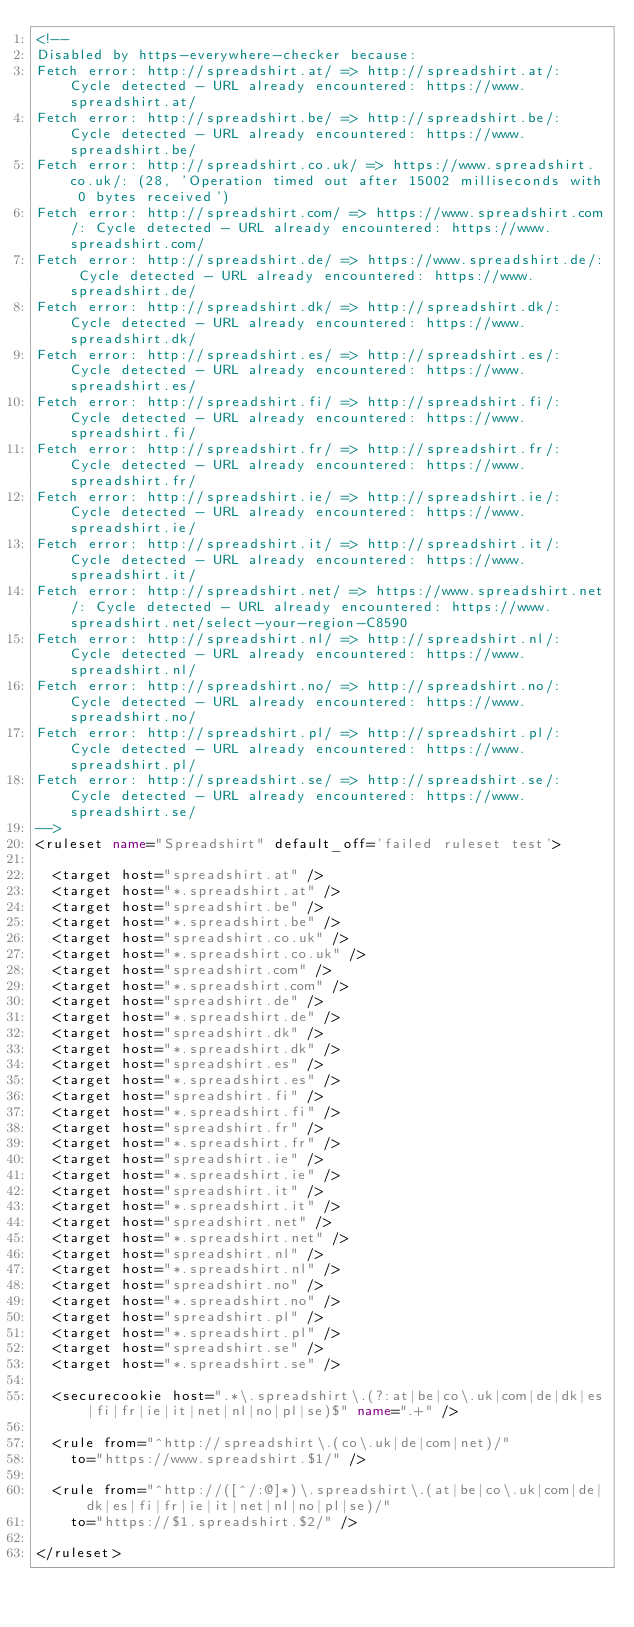<code> <loc_0><loc_0><loc_500><loc_500><_XML_><!--
Disabled by https-everywhere-checker because:
Fetch error: http://spreadshirt.at/ => http://spreadshirt.at/: Cycle detected - URL already encountered: https://www.spreadshirt.at/
Fetch error: http://spreadshirt.be/ => http://spreadshirt.be/: Cycle detected - URL already encountered: https://www.spreadshirt.be/
Fetch error: http://spreadshirt.co.uk/ => https://www.spreadshirt.co.uk/: (28, 'Operation timed out after 15002 milliseconds with 0 bytes received')
Fetch error: http://spreadshirt.com/ => https://www.spreadshirt.com/: Cycle detected - URL already encountered: https://www.spreadshirt.com/
Fetch error: http://spreadshirt.de/ => https://www.spreadshirt.de/: Cycle detected - URL already encountered: https://www.spreadshirt.de/
Fetch error: http://spreadshirt.dk/ => http://spreadshirt.dk/: Cycle detected - URL already encountered: https://www.spreadshirt.dk/
Fetch error: http://spreadshirt.es/ => http://spreadshirt.es/: Cycle detected - URL already encountered: https://www.spreadshirt.es/
Fetch error: http://spreadshirt.fi/ => http://spreadshirt.fi/: Cycle detected - URL already encountered: https://www.spreadshirt.fi/
Fetch error: http://spreadshirt.fr/ => http://spreadshirt.fr/: Cycle detected - URL already encountered: https://www.spreadshirt.fr/
Fetch error: http://spreadshirt.ie/ => http://spreadshirt.ie/: Cycle detected - URL already encountered: https://www.spreadshirt.ie/
Fetch error: http://spreadshirt.it/ => http://spreadshirt.it/: Cycle detected - URL already encountered: https://www.spreadshirt.it/
Fetch error: http://spreadshirt.net/ => https://www.spreadshirt.net/: Cycle detected - URL already encountered: https://www.spreadshirt.net/select-your-region-C8590
Fetch error: http://spreadshirt.nl/ => http://spreadshirt.nl/: Cycle detected - URL already encountered: https://www.spreadshirt.nl/
Fetch error: http://spreadshirt.no/ => http://spreadshirt.no/: Cycle detected - URL already encountered: https://www.spreadshirt.no/
Fetch error: http://spreadshirt.pl/ => http://spreadshirt.pl/: Cycle detected - URL already encountered: https://www.spreadshirt.pl/
Fetch error: http://spreadshirt.se/ => http://spreadshirt.se/: Cycle detected - URL already encountered: https://www.spreadshirt.se/
-->
<ruleset name="Spreadshirt" default_off='failed ruleset test'>

	<target host="spreadshirt.at" />
	<target host="*.spreadshirt.at" />
	<target host="spreadshirt.be" />
	<target host="*.spreadshirt.be" />
	<target host="spreadshirt.co.uk" />
	<target host="*.spreadshirt.co.uk" />
	<target host="spreadshirt.com" />
	<target host="*.spreadshirt.com" />
	<target host="spreadshirt.de" />
	<target host="*.spreadshirt.de" />
	<target host="spreadshirt.dk" />
	<target host="*.spreadshirt.dk" />
	<target host="spreadshirt.es" />
	<target host="*.spreadshirt.es" />
	<target host="spreadshirt.fi" />
	<target host="*.spreadshirt.fi" />
	<target host="spreadshirt.fr" />
	<target host="*.spreadshirt.fr" />
	<target host="spreadshirt.ie" />
	<target host="*.spreadshirt.ie" />
	<target host="spreadshirt.it" />
	<target host="*.spreadshirt.it" />
	<target host="spreadshirt.net" />
	<target host="*.spreadshirt.net" />
	<target host="spreadshirt.nl" />
	<target host="*.spreadshirt.nl" />
	<target host="spreadshirt.no" />
	<target host="*.spreadshirt.no" />
	<target host="spreadshirt.pl" />
	<target host="*.spreadshirt.pl" />
	<target host="spreadshirt.se" />
	<target host="*.spreadshirt.se" />

	<securecookie host=".*\.spreadshirt\.(?:at|be|co\.uk|com|de|dk|es|fi|fr|ie|it|net|nl|no|pl|se)$" name=".+" />

	<rule from="^http://spreadshirt\.(co\.uk|de|com|net)/"
		to="https://www.spreadshirt.$1/" />

	<rule from="^http://([^/:@]*)\.spreadshirt\.(at|be|co\.uk|com|de|dk|es|fi|fr|ie|it|net|nl|no|pl|se)/"
		to="https://$1.spreadshirt.$2/" />

</ruleset>
</code> 